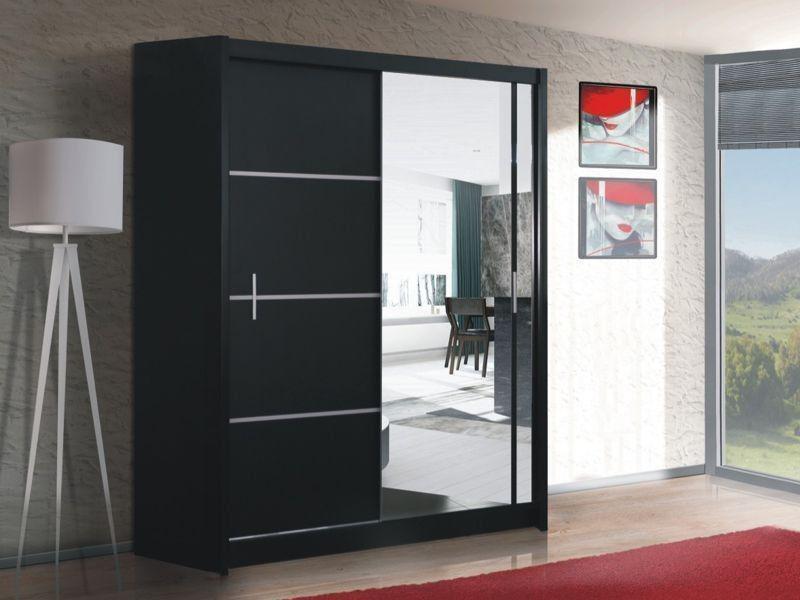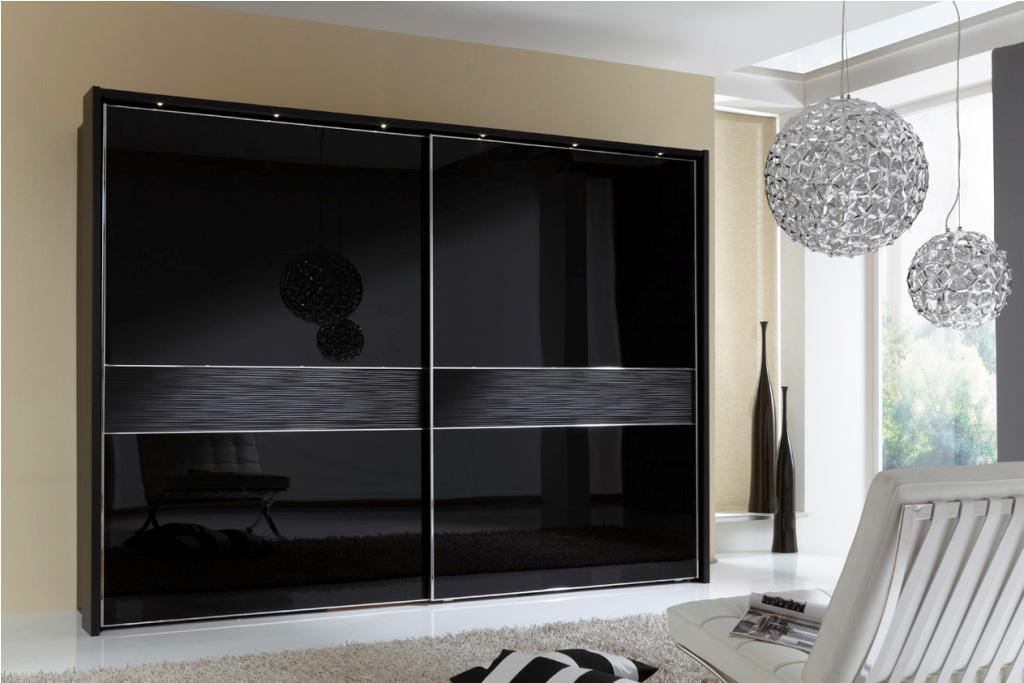The first image is the image on the left, the second image is the image on the right. For the images displayed, is the sentence "An image shows a wardrobe with mirror on the right and black panel on the left." factually correct? Answer yes or no. Yes. 